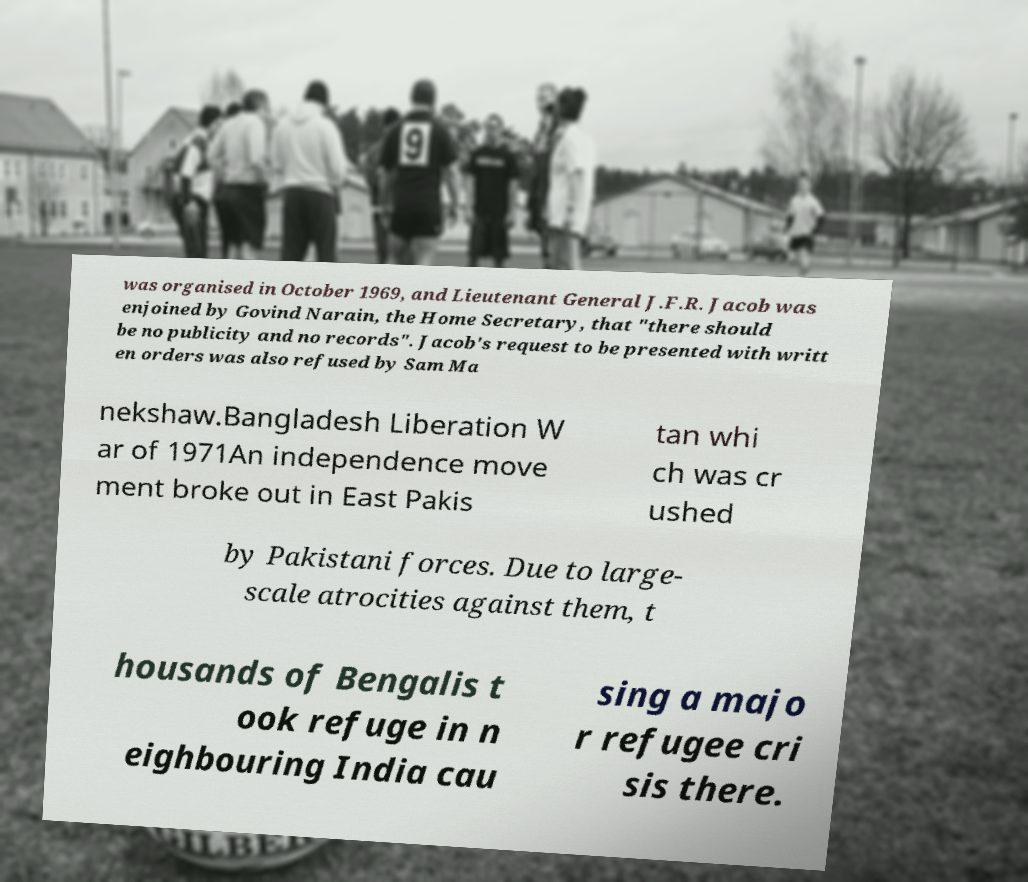There's text embedded in this image that I need extracted. Can you transcribe it verbatim? was organised in October 1969, and Lieutenant General J.F.R. Jacob was enjoined by Govind Narain, the Home Secretary, that "there should be no publicity and no records". Jacob's request to be presented with writt en orders was also refused by Sam Ma nekshaw.Bangladesh Liberation W ar of 1971An independence move ment broke out in East Pakis tan whi ch was cr ushed by Pakistani forces. Due to large- scale atrocities against them, t housands of Bengalis t ook refuge in n eighbouring India cau sing a majo r refugee cri sis there. 